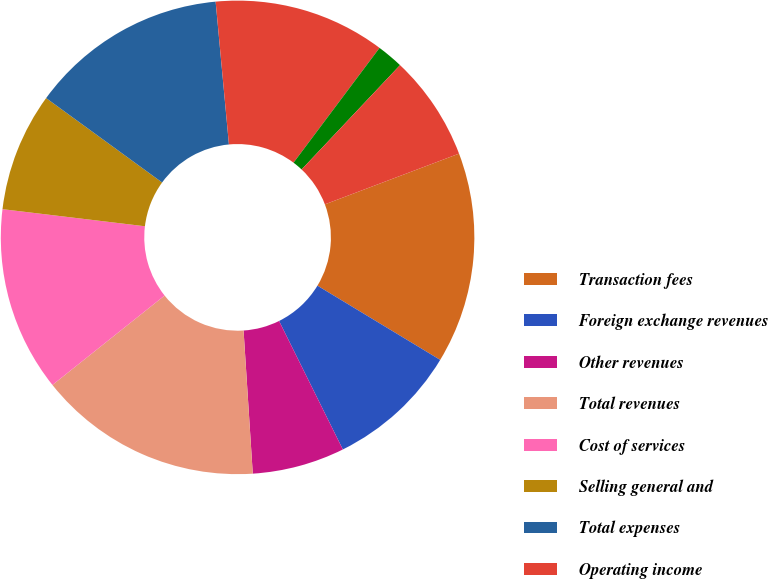<chart> <loc_0><loc_0><loc_500><loc_500><pie_chart><fcel>Transaction fees<fcel>Foreign exchange revenues<fcel>Other revenues<fcel>Total revenues<fcel>Cost of services<fcel>Selling general and<fcel>Total expenses<fcel>Operating income<fcel>Interest income<fcel>Interest expense<nl><fcel>14.41%<fcel>9.01%<fcel>6.31%<fcel>15.31%<fcel>12.61%<fcel>8.11%<fcel>13.51%<fcel>11.71%<fcel>1.8%<fcel>7.21%<nl></chart> 